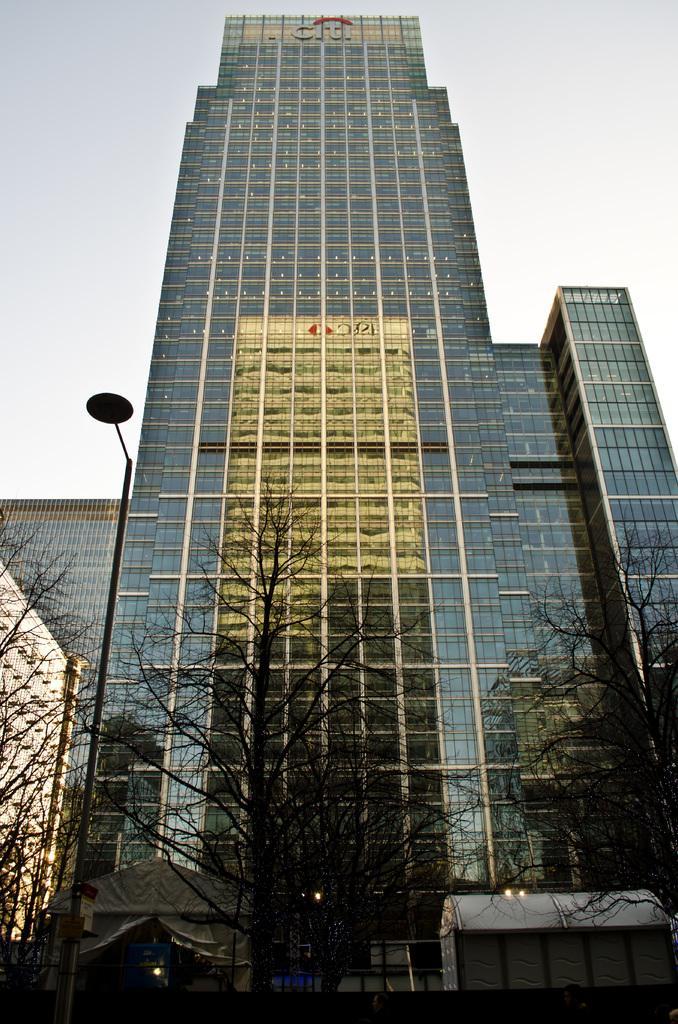In one or two sentences, can you explain what this image depicts? This image consists of a building. At the bottom, there are trees. On the left, we can see a pole. At the top, there is sky. 